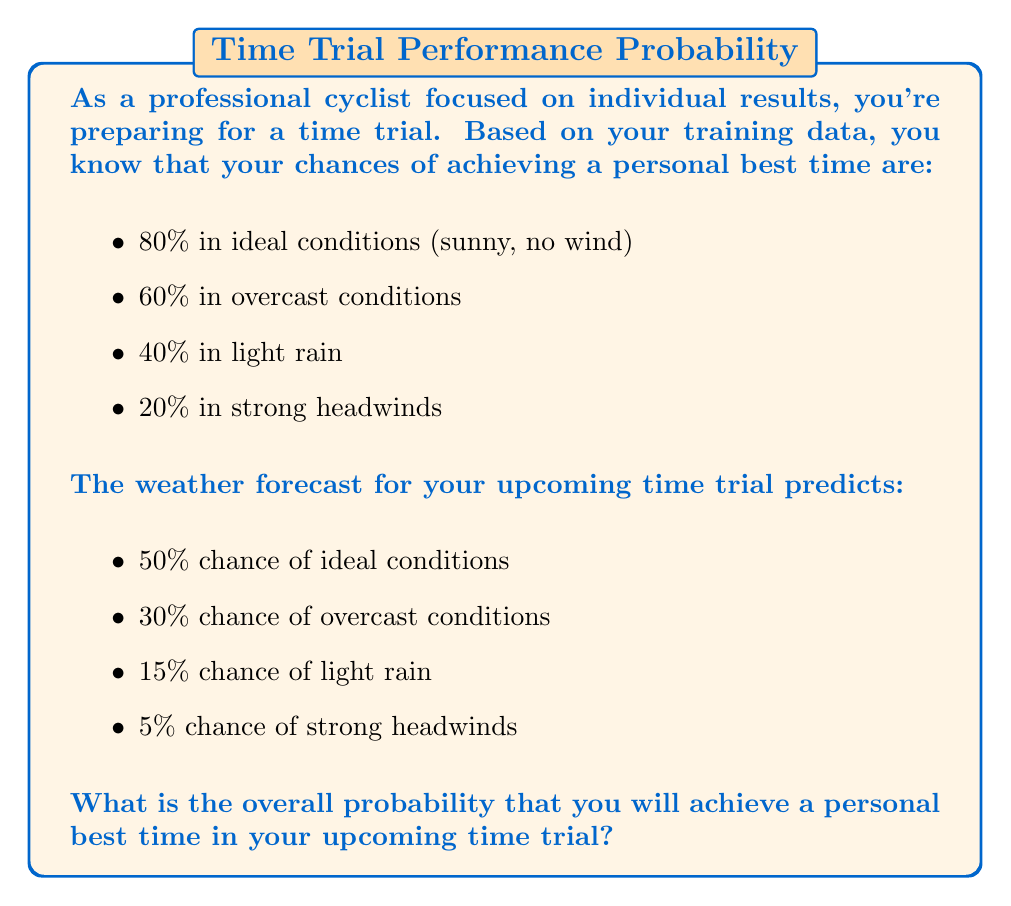Solve this math problem. To solve this problem, we'll use the law of total probability. We need to calculate the probability of achieving a personal best time for each possible weather condition and then sum these probabilities.

Let A be the event of achieving a personal best time.
Let W1, W2, W3, and W4 be the events of ideal, overcast, light rain, and strong headwind conditions respectively.

We can calculate the probability of achieving a personal best time as follows:

$$P(A) = P(A|W1)P(W1) + P(A|W2)P(W2) + P(A|W3)P(W3) + P(A|W4)P(W4)$$

Where:
$P(A|W1) = 0.80$, $P(W1) = 0.50$
$P(A|W2) = 0.60$, $P(W2) = 0.30$
$P(A|W3) = 0.40$, $P(W3) = 0.15$
$P(A|W4) = 0.20$, $P(W4) = 0.05$

Substituting these values:

$$P(A) = (0.80 \times 0.50) + (0.60 \times 0.30) + (0.40 \times 0.15) + (0.20 \times 0.05)$$

$$P(A) = 0.40 + 0.18 + 0.06 + 0.01$$

$$P(A) = 0.65$$

Therefore, the overall probability of achieving a personal best time is 0.65 or 65%.
Answer: The overall probability of achieving a personal best time in the upcoming time trial is 0.65 or 65%. 